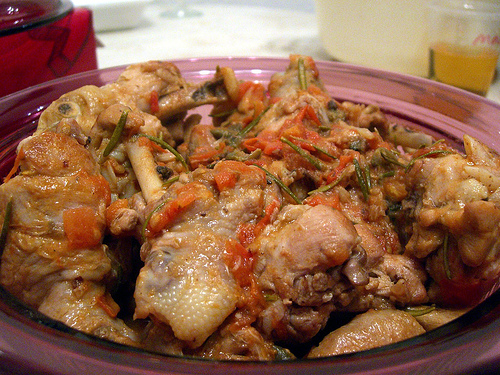<image>
Is the chicken in the plate? No. The chicken is not contained within the plate. These objects have a different spatial relationship. 